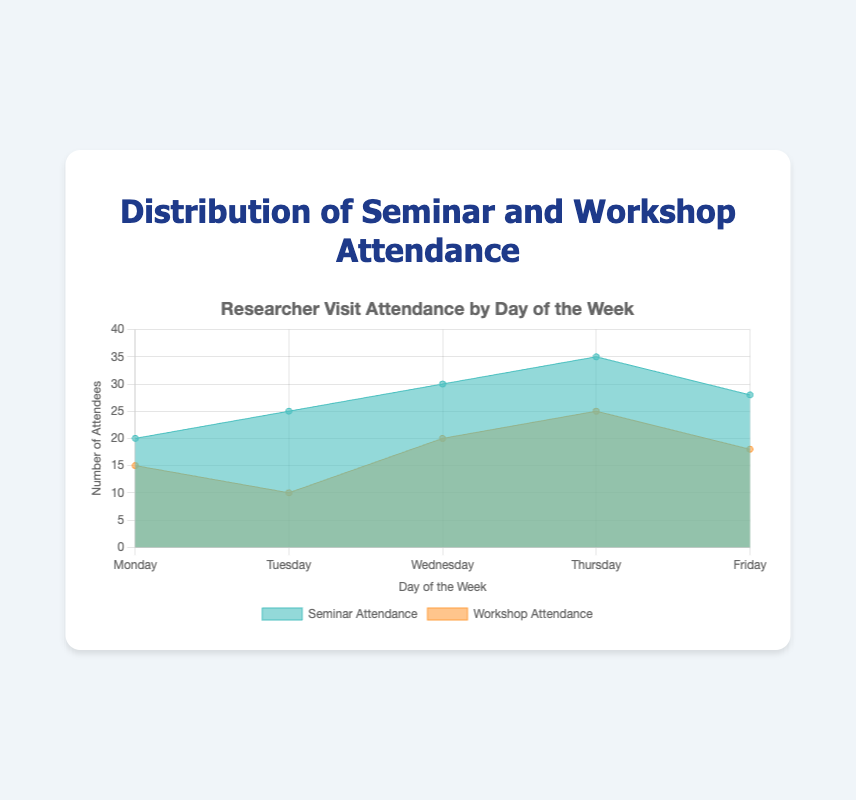What's the total number of attendees on Wednesday? The number of seminar attendees on Wednesday is 30, and the number of workshop attendees is 20. Adding these together gives 30 + 20 = 50.
Answer: 50 How does Friday's seminar attendance compare to Thursday's? Friday has 28 seminar attendees, while Thursday has 35. Since 28 is less than 35, Friday's seminar attendance is lower than Thursday's.
Answer: Friday's seminar attendance is lower Which day has the highest total attendance (seminar and workshop combined)? To find the total attendance for each day: Monday (20 + 15 = 35), Tuesday (25 + 10 = 35), Wednesday (30 + 20 = 50), Thursday (35 + 25 = 60), and Friday (28 + 18 = 46). Thursday has the highest total attendance with 60.
Answer: Thursday On which day is the difference between seminar and workshop attendance the smallest? Calculate the differences for each day: Monday (20 - 15 = 5), Tuesday (25 - 10 = 15), Wednesday (30 - 20 = 10), Thursday (35 - 25 = 10), and Friday (28 - 18 = 10). The smallest difference is on Monday with a difference of 5.
Answer: Monday What's the average seminar attendance for the week? Sum the seminar attendances: 20 + 25 + 30 + 35 + 28 = 138. Divide by the number of days (5): 138 / 5 = 27.6.
Answer: 27.6 Which day has the highest workshop attendance? By looking at the workshop attendance values, Thursday has the highest with 25 attendees.
Answer: Thursday Compare the total attendance on Monday versus Tuesday. Which day has a higher total? Monday's total attendance is 35 (20 seminar + 15 workshop) and Tuesday's total is 35 (25 seminar + 10 workshop). Both days have the same total attendance.
Answer: Both days are equal What's the total number of workshop attendees throughout the week? Add the workshop attendance for all days: 15 + 10 + 20 + 25 + 18 = 88.
Answer: 88 On which day is the difference between seminar attendance and workshop attendance the largest? Calculate the differences for each day: Monday (20 - 15 = 5), Tuesday (25 - 10 = 15), Wednesday (30 - 20 = 10), Thursday (35 - 25 = 10), and Friday (28 - 18 = 10). The largest difference is on Tuesday with a difference of 15.
Answer: Tuesday 